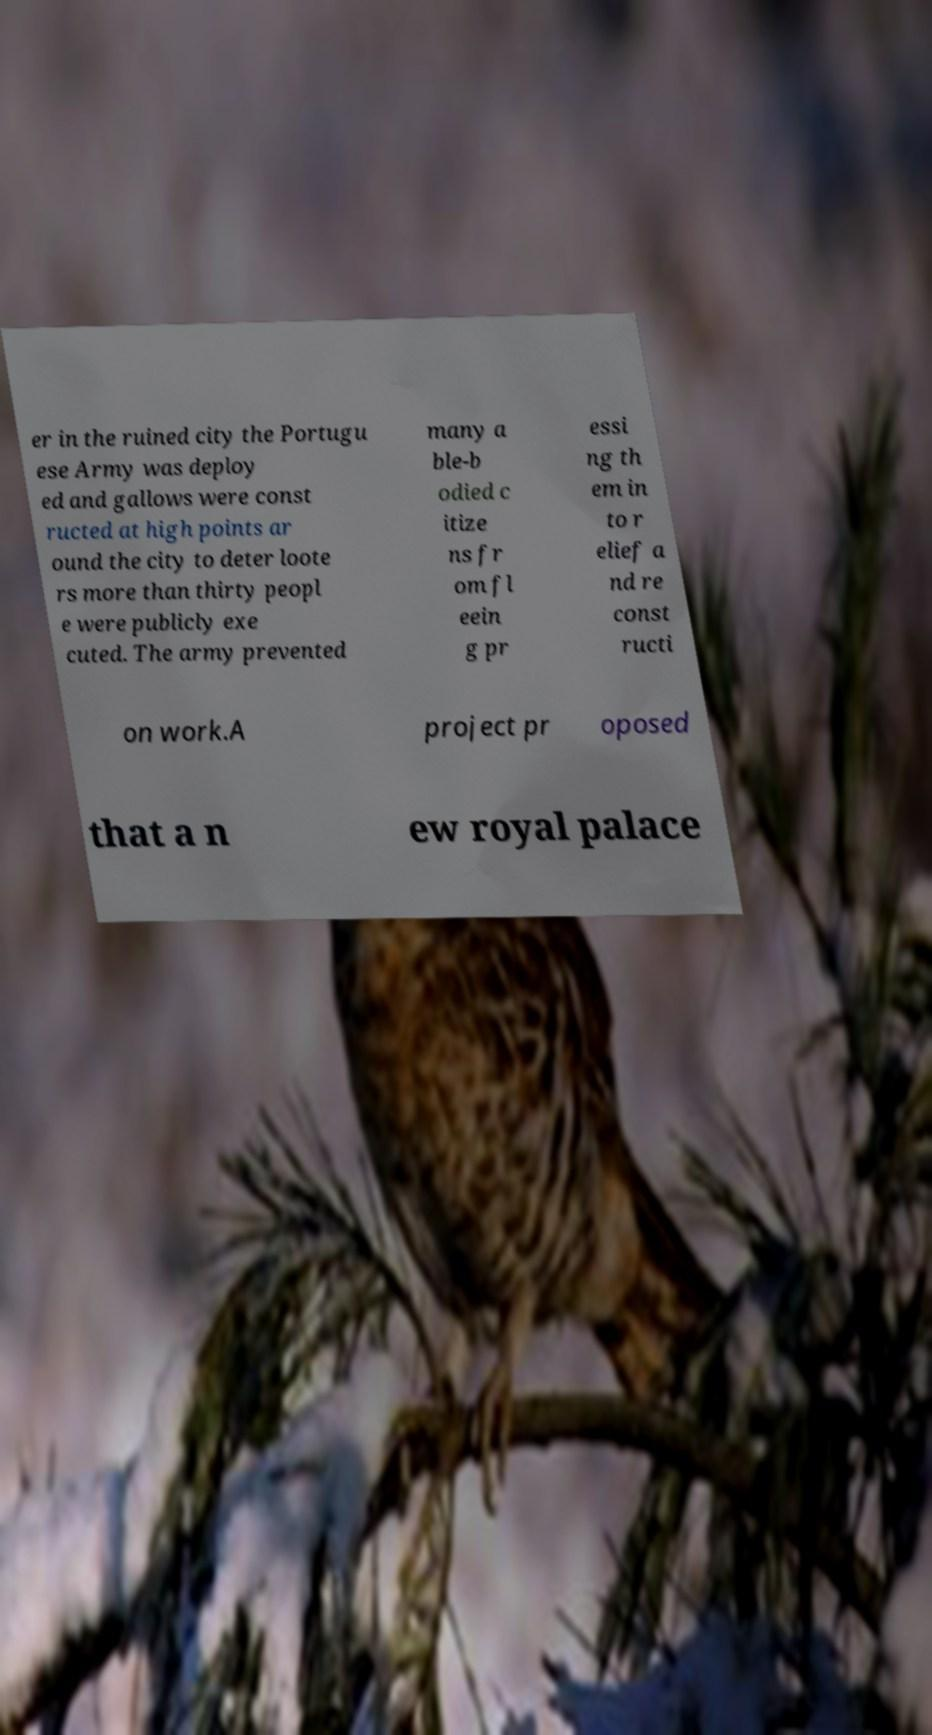I need the written content from this picture converted into text. Can you do that? er in the ruined city the Portugu ese Army was deploy ed and gallows were const ructed at high points ar ound the city to deter loote rs more than thirty peopl e were publicly exe cuted. The army prevented many a ble-b odied c itize ns fr om fl eein g pr essi ng th em in to r elief a nd re const ructi on work.A project pr oposed that a n ew royal palace 